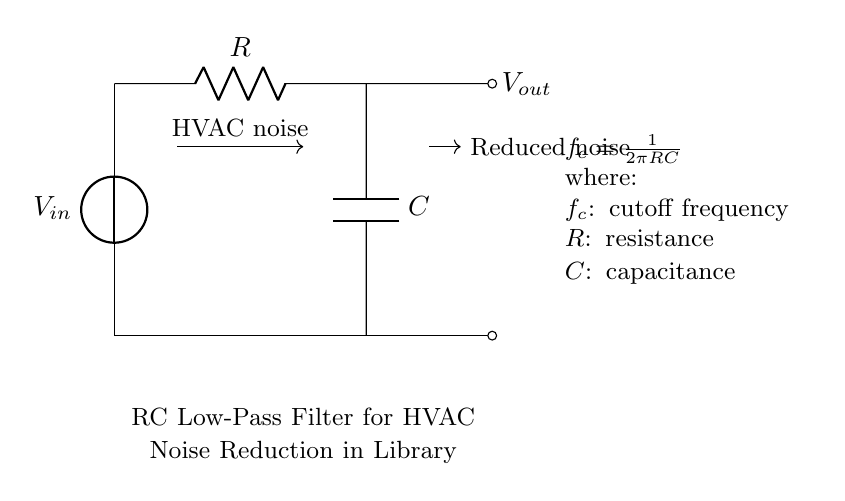What are the components of this circuit? The circuit contains a voltage source, a resistor, and a capacitor, which are standard components in an RC low-pass filter.
Answer: voltage source, resistor, capacitor What does the symbol 'C' represent? The symbol 'C' in the circuit represents capacitance. In this context, it is used to filter out high frequencies and reduce noise in the HVAC system.
Answer: capacitance What is the function of the resistor in this circuit? The resistor, labeled 'R', works in conjunction with the capacitor to determine the cutoff frequency of the low-pass filter, impacting how quickly the circuit responds to changes in the input signal.
Answer: cutoff frequency determination How is the cutoff frequency calculated? The cutoff frequency 'f_c' is calculated using the formula f_c equals one divided by two pi times resistance times capacitance, combining both values to find where the circuit begins to attenuate higher frequencies.
Answer: one divided by two pi RC What happens to the HVAC noise as it passes through this circuit? As the HVAC noise (input voltage) passes through the low-pass filter, it is reduced in amplitude, effectively filtering out higher frequency noise, resulting in a smoother and quieter signal at the output.
Answer: reduced in amplitude If the resistance is doubled, how does it affect the cutoff frequency? If the resistance is doubled, the cutoff frequency decreases according to the formula; since 'f_c' is inversely proportional to 'R', increasing 'R' decreases 'f_c', allowing lower frequencies to pass through and reducing the filter's response to noise.
Answer: cutoff frequency decreases What does 'V_out' signify in this circuit? 'V_out' denotes the output voltage, which is the reduced noise level after the input signal passes through the RC low-pass filter. It indicates the effectiveness of the circuit in noise reduction.
Answer: reduced noise level 